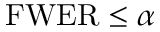Convert formula to latex. <formula><loc_0><loc_0><loc_500><loc_500>F W E R \leq \alpha \,</formula> 